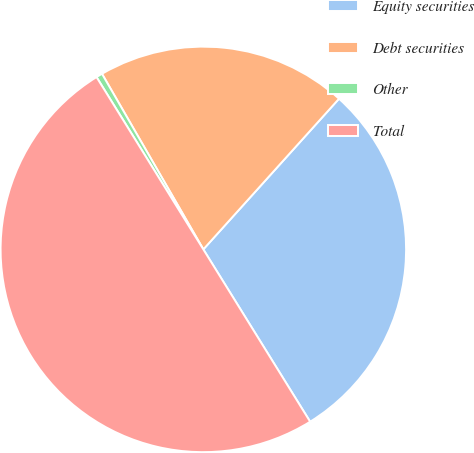Convert chart. <chart><loc_0><loc_0><loc_500><loc_500><pie_chart><fcel>Equity securities<fcel>Debt securities<fcel>Other<fcel>Total<nl><fcel>29.5%<fcel>20.0%<fcel>0.5%<fcel>50.0%<nl></chart> 